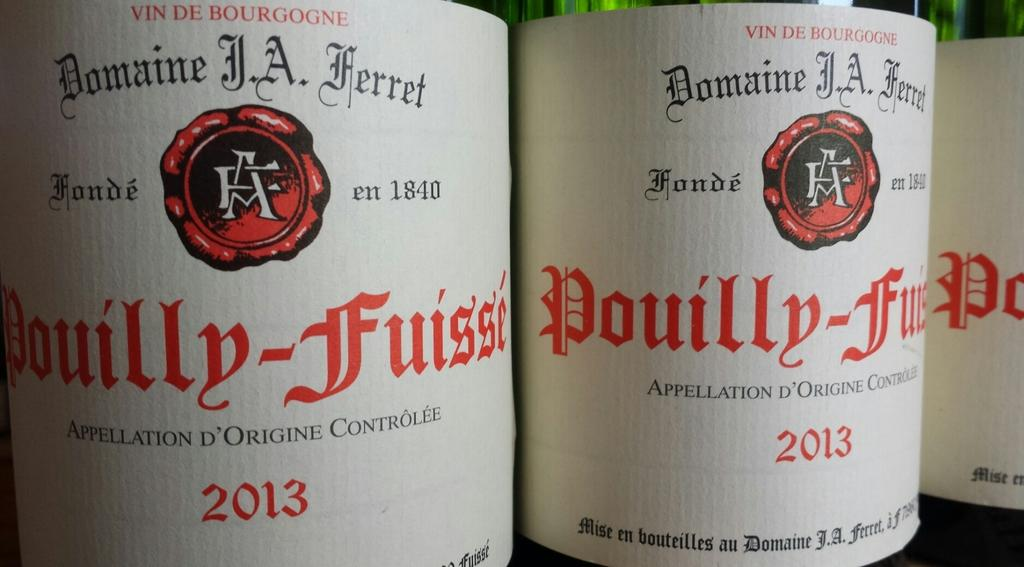<image>
Describe the image concisely. The label of a bottle named "Douilly-Fuisse" made in 2013. 